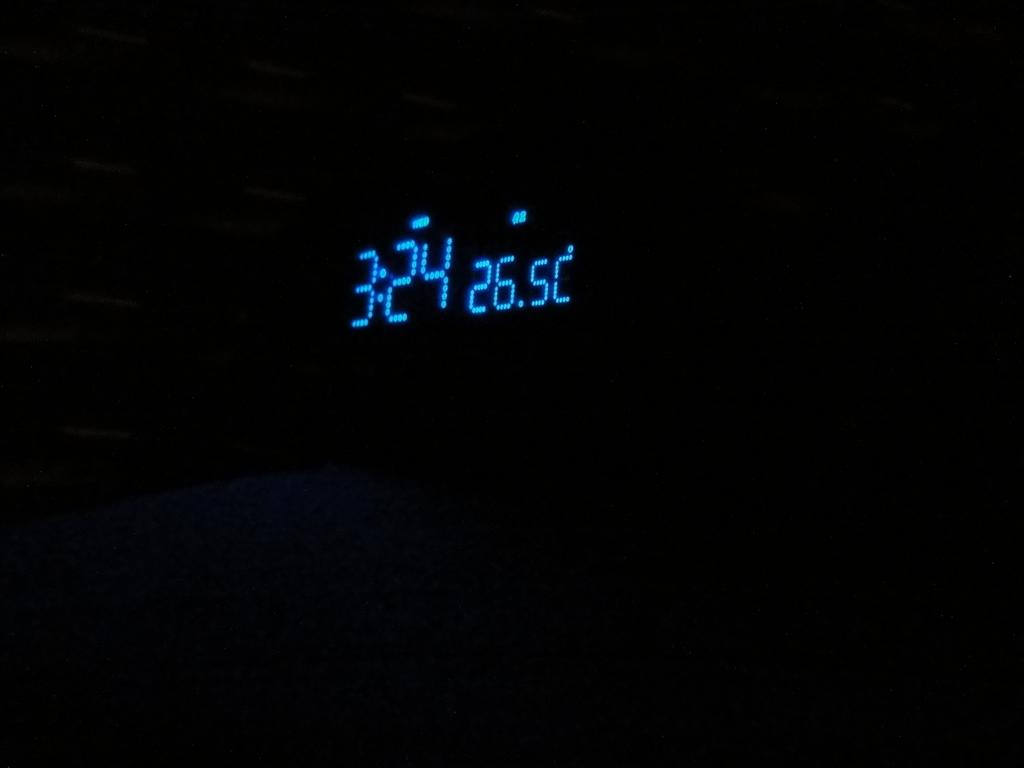<image>
Present a compact description of the photo's key features. A digital clock shows blue numbers of 3:24. 